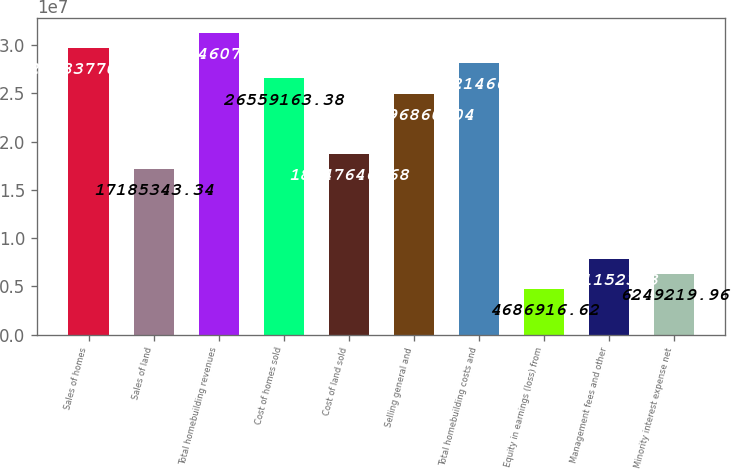Convert chart to OTSL. <chart><loc_0><loc_0><loc_500><loc_500><bar_chart><fcel>Sales of homes<fcel>Sales of land<fcel>Total homebuilding revenues<fcel>Cost of homes sold<fcel>Cost of land sold<fcel>Selling general and<fcel>Total homebuilding costs and<fcel>Equity in earnings (loss) from<fcel>Management fees and other<fcel>Minority interest expense net<nl><fcel>2.96838e+07<fcel>1.71853e+07<fcel>3.12461e+07<fcel>2.65592e+07<fcel>1.87476e+07<fcel>2.49969e+07<fcel>2.81215e+07<fcel>4.68692e+06<fcel>7.81152e+06<fcel>6.24922e+06<nl></chart> 